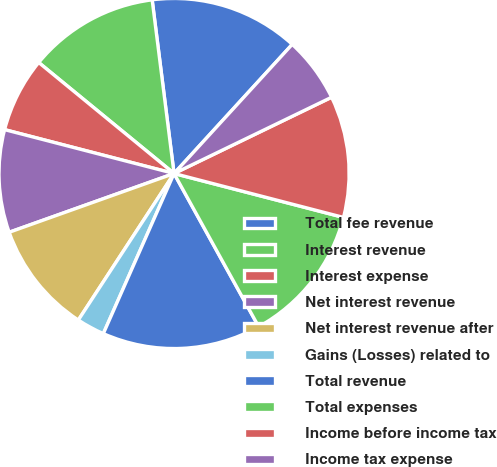Convert chart to OTSL. <chart><loc_0><loc_0><loc_500><loc_500><pie_chart><fcel>Total fee revenue<fcel>Interest revenue<fcel>Interest expense<fcel>Net interest revenue<fcel>Net interest revenue after<fcel>Gains (Losses) related to<fcel>Total revenue<fcel>Total expenses<fcel>Income before income tax<fcel>Income tax expense<nl><fcel>13.79%<fcel>12.07%<fcel>6.9%<fcel>9.48%<fcel>10.34%<fcel>2.59%<fcel>14.65%<fcel>12.93%<fcel>11.21%<fcel>6.03%<nl></chart> 